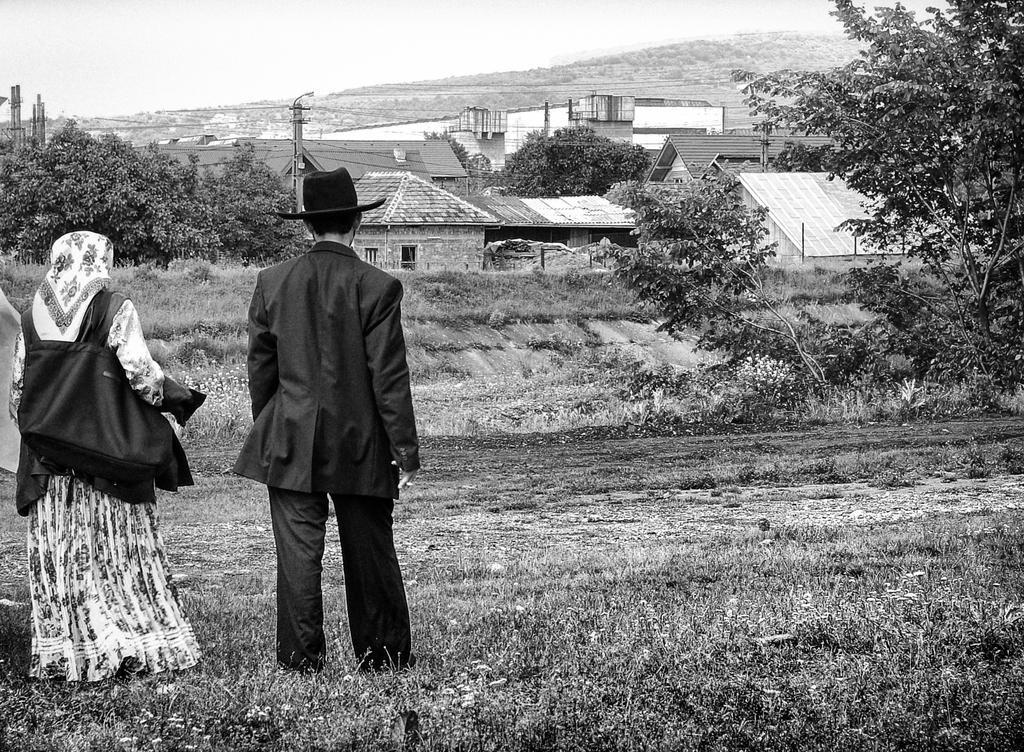Please provide a concise description of this image. In this picture there is a man and a woman on the left side of the image, they are standing facing towards the background and there is grass land at the bottom side of the image and there are houses and trees in the background area of the image. 